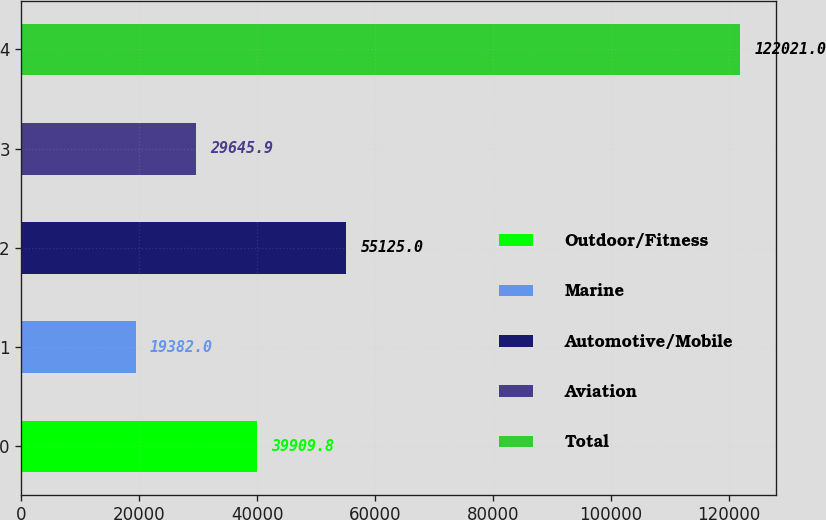<chart> <loc_0><loc_0><loc_500><loc_500><bar_chart><fcel>Outdoor/Fitness<fcel>Marine<fcel>Automotive/Mobile<fcel>Aviation<fcel>Total<nl><fcel>39909.8<fcel>19382<fcel>55125<fcel>29645.9<fcel>122021<nl></chart> 